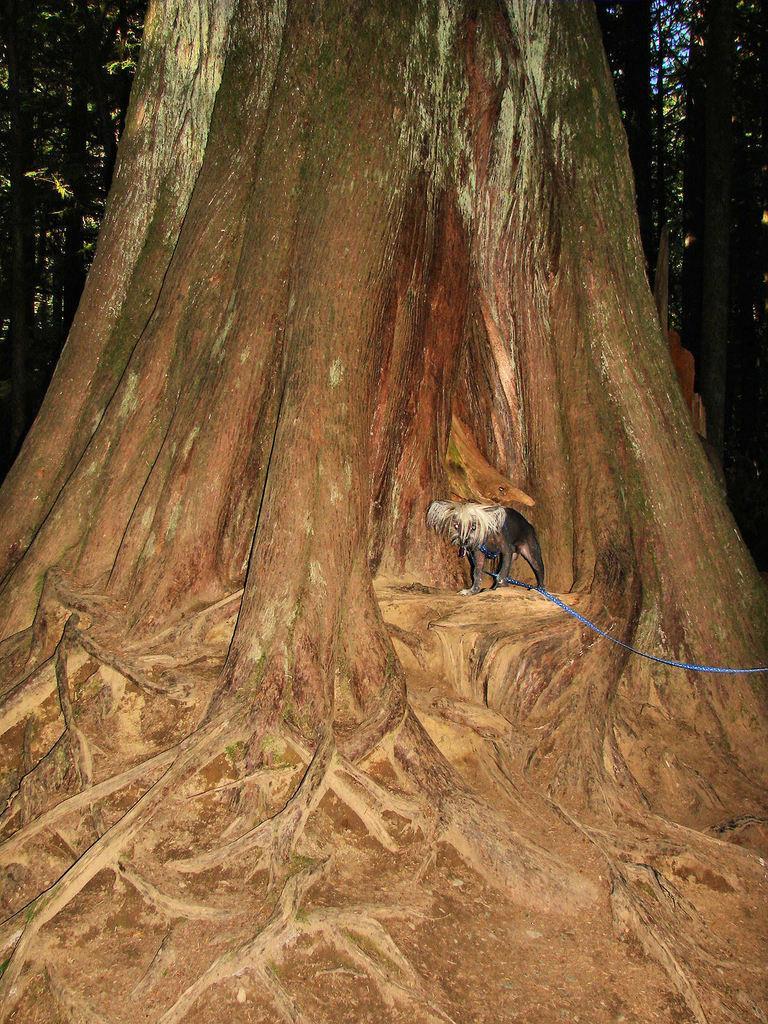Could you give a brief overview of what you see in this image? In the image we can see there is a dog standing under the tree and behind there are lot of trees. 